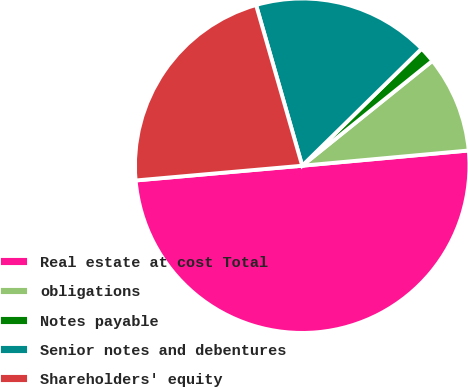<chart> <loc_0><loc_0><loc_500><loc_500><pie_chart><fcel>Real estate at cost Total<fcel>obligations<fcel>Notes payable<fcel>Senior notes and debentures<fcel>Shareholders' equity<nl><fcel>50.05%<fcel>9.34%<fcel>1.55%<fcel>17.11%<fcel>21.96%<nl></chart> 